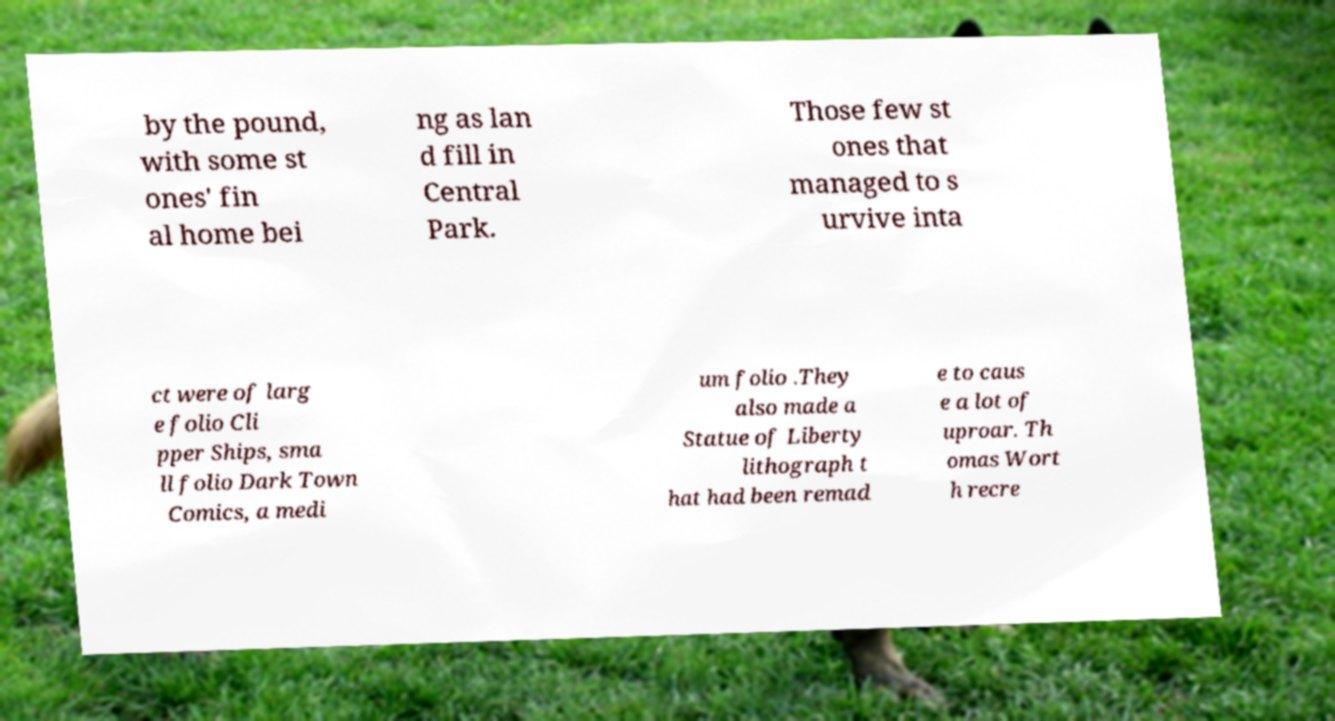Could you extract and type out the text from this image? by the pound, with some st ones' fin al home bei ng as lan d fill in Central Park. Those few st ones that managed to s urvive inta ct were of larg e folio Cli pper Ships, sma ll folio Dark Town Comics, a medi um folio .They also made a Statue of Liberty lithograph t hat had been remad e to caus e a lot of uproar. Th omas Wort h recre 